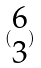Convert formula to latex. <formula><loc_0><loc_0><loc_500><loc_500>( \begin{matrix} 6 \\ 3 \end{matrix} )</formula> 